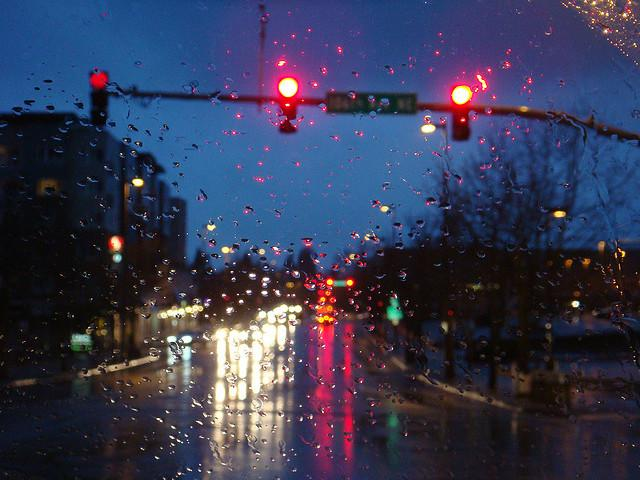What's seen on the window?

Choices:
A) insects
B) fingerprints
C) raindrops
D) stickers raindrops 